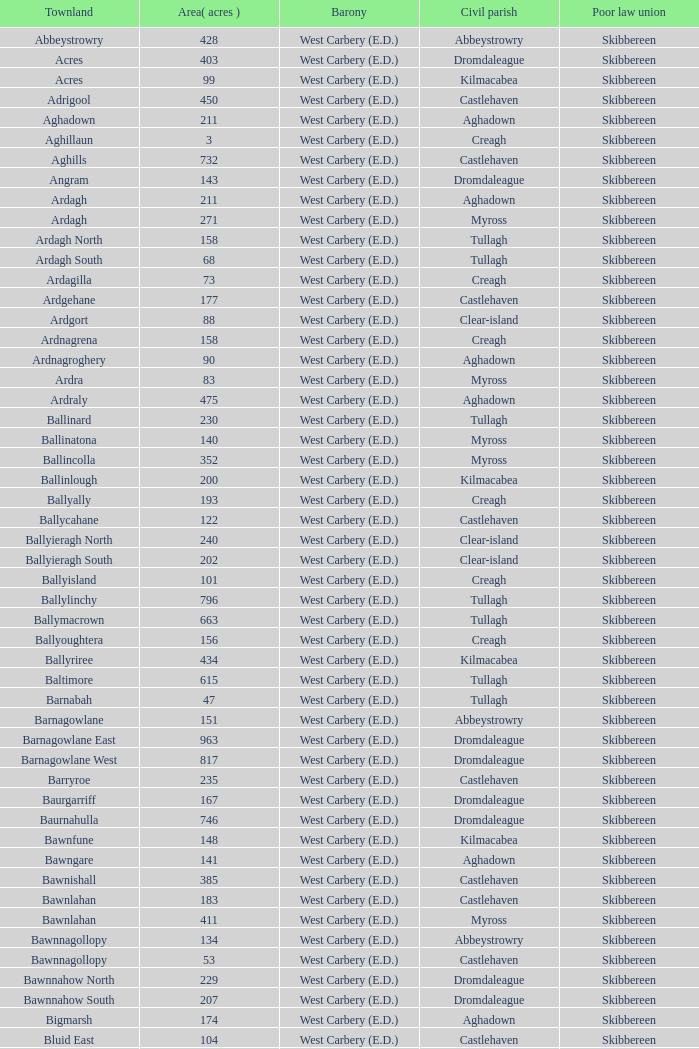What is the largest area when the poor law union is skibbereen and the civil parish is tullagh? 796.0. 